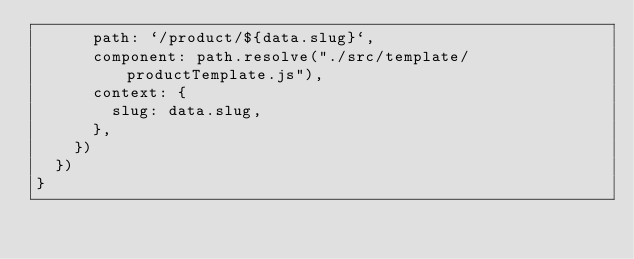<code> <loc_0><loc_0><loc_500><loc_500><_JavaScript_>      path: `/product/${data.slug}`,
      component: path.resolve("./src/template/productTemplate.js"),
      context: {
        slug: data.slug,
      },
    })
  })
}
</code> 